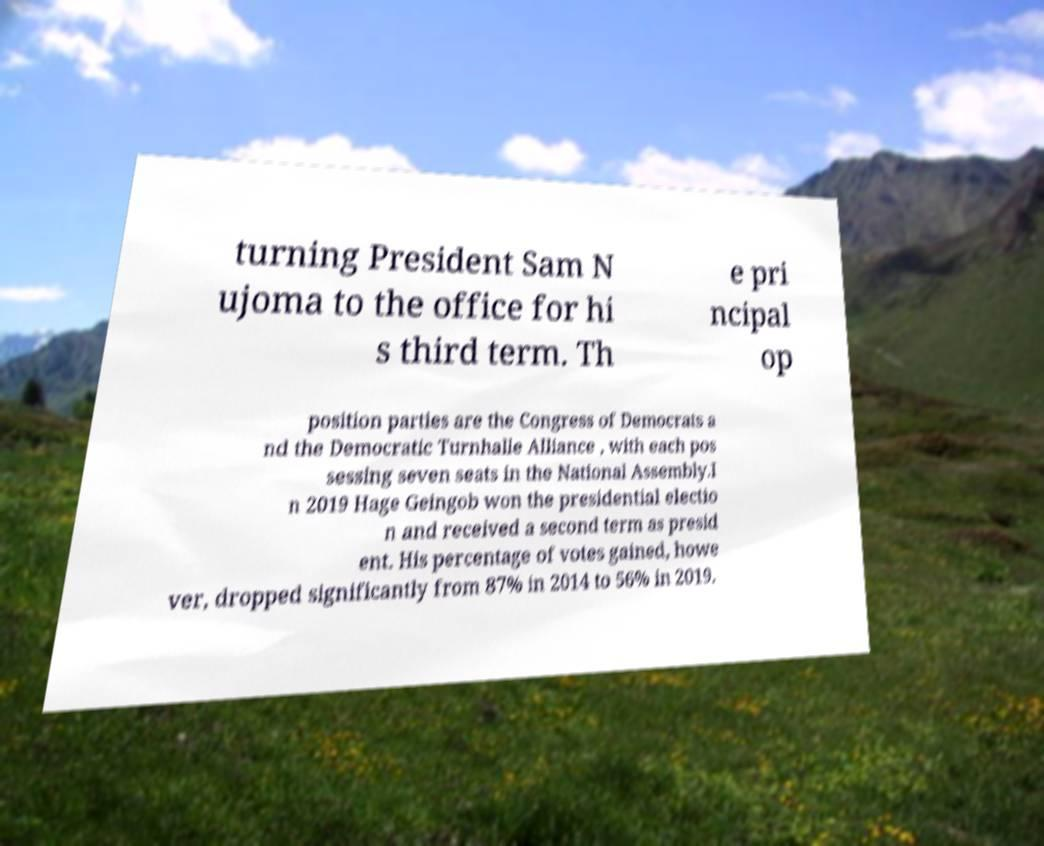Can you accurately transcribe the text from the provided image for me? turning President Sam N ujoma to the office for hi s third term. Th e pri ncipal op position parties are the Congress of Democrats a nd the Democratic Turnhalle Alliance , with each pos sessing seven seats in the National Assembly.I n 2019 Hage Geingob won the presidential electio n and received a second term as presid ent. His percentage of votes gained, howe ver, dropped significantly from 87% in 2014 to 56% in 2019. 